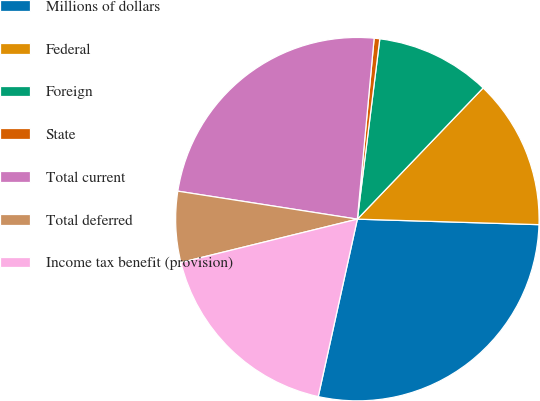Convert chart to OTSL. <chart><loc_0><loc_0><loc_500><loc_500><pie_chart><fcel>Millions of dollars<fcel>Federal<fcel>Foreign<fcel>State<fcel>Total current<fcel>Total deferred<fcel>Income tax benefit (provision)<nl><fcel>27.97%<fcel>13.32%<fcel>10.19%<fcel>0.5%<fcel>24.01%<fcel>6.3%<fcel>17.71%<nl></chart> 